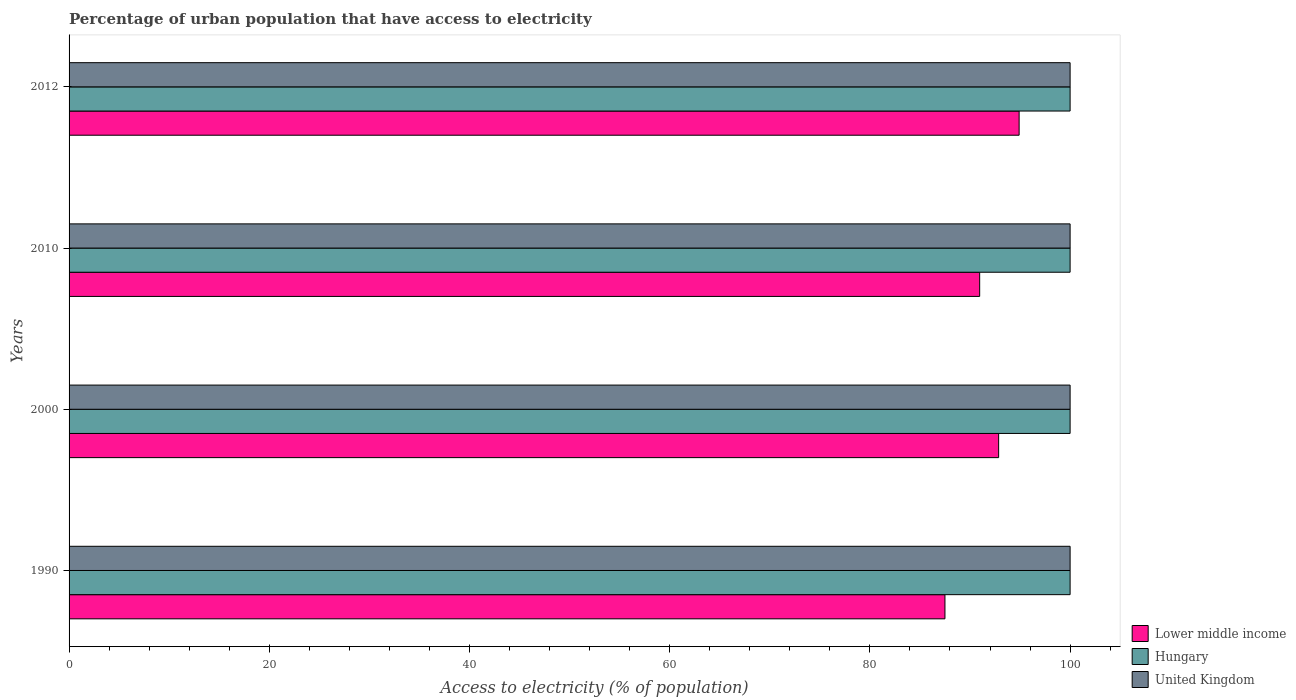How many different coloured bars are there?
Provide a succinct answer. 3. What is the label of the 3rd group of bars from the top?
Your answer should be compact. 2000. In how many cases, is the number of bars for a given year not equal to the number of legend labels?
Give a very brief answer. 0. What is the percentage of urban population that have access to electricity in Hungary in 1990?
Make the answer very short. 100. Across all years, what is the maximum percentage of urban population that have access to electricity in United Kingdom?
Ensure brevity in your answer.  100. Across all years, what is the minimum percentage of urban population that have access to electricity in United Kingdom?
Your answer should be very brief. 100. What is the total percentage of urban population that have access to electricity in United Kingdom in the graph?
Make the answer very short. 400. What is the difference between the percentage of urban population that have access to electricity in Hungary in 1990 and that in 2010?
Your answer should be very brief. 0. What is the difference between the percentage of urban population that have access to electricity in Hungary in 1990 and the percentage of urban population that have access to electricity in Lower middle income in 2000?
Your answer should be very brief. 7.14. In the year 2000, what is the difference between the percentage of urban population that have access to electricity in Lower middle income and percentage of urban population that have access to electricity in United Kingdom?
Keep it short and to the point. -7.14. What is the ratio of the percentage of urban population that have access to electricity in Lower middle income in 2010 to that in 2012?
Ensure brevity in your answer.  0.96. Is the difference between the percentage of urban population that have access to electricity in Lower middle income in 2000 and 2012 greater than the difference between the percentage of urban population that have access to electricity in United Kingdom in 2000 and 2012?
Provide a succinct answer. No. What does the 1st bar from the top in 2000 represents?
Offer a terse response. United Kingdom. What does the 1st bar from the bottom in 2000 represents?
Your answer should be very brief. Lower middle income. Is it the case that in every year, the sum of the percentage of urban population that have access to electricity in Hungary and percentage of urban population that have access to electricity in Lower middle income is greater than the percentage of urban population that have access to electricity in United Kingdom?
Your response must be concise. Yes. Are all the bars in the graph horizontal?
Your response must be concise. Yes. How many years are there in the graph?
Your answer should be very brief. 4. What is the difference between two consecutive major ticks on the X-axis?
Provide a succinct answer. 20. Are the values on the major ticks of X-axis written in scientific E-notation?
Keep it short and to the point. No. Where does the legend appear in the graph?
Offer a very short reply. Bottom right. How many legend labels are there?
Your answer should be very brief. 3. What is the title of the graph?
Offer a terse response. Percentage of urban population that have access to electricity. Does "Luxembourg" appear as one of the legend labels in the graph?
Offer a very short reply. No. What is the label or title of the X-axis?
Ensure brevity in your answer.  Access to electricity (% of population). What is the Access to electricity (% of population) in Lower middle income in 1990?
Make the answer very short. 87.5. What is the Access to electricity (% of population) of United Kingdom in 1990?
Your response must be concise. 100. What is the Access to electricity (% of population) of Lower middle income in 2000?
Offer a terse response. 92.86. What is the Access to electricity (% of population) of Lower middle income in 2010?
Your answer should be very brief. 90.97. What is the Access to electricity (% of population) in Lower middle income in 2012?
Provide a short and direct response. 94.91. What is the Access to electricity (% of population) in Hungary in 2012?
Offer a terse response. 100. What is the Access to electricity (% of population) in United Kingdom in 2012?
Your response must be concise. 100. Across all years, what is the maximum Access to electricity (% of population) in Lower middle income?
Make the answer very short. 94.91. Across all years, what is the maximum Access to electricity (% of population) in United Kingdom?
Keep it short and to the point. 100. Across all years, what is the minimum Access to electricity (% of population) of Lower middle income?
Offer a very short reply. 87.5. What is the total Access to electricity (% of population) in Lower middle income in the graph?
Your answer should be compact. 366.23. What is the total Access to electricity (% of population) of Hungary in the graph?
Keep it short and to the point. 400. What is the difference between the Access to electricity (% of population) in Lower middle income in 1990 and that in 2000?
Give a very brief answer. -5.36. What is the difference between the Access to electricity (% of population) of Hungary in 1990 and that in 2000?
Offer a terse response. 0. What is the difference between the Access to electricity (% of population) in Lower middle income in 1990 and that in 2010?
Your response must be concise. -3.47. What is the difference between the Access to electricity (% of population) in Hungary in 1990 and that in 2010?
Offer a very short reply. 0. What is the difference between the Access to electricity (% of population) of United Kingdom in 1990 and that in 2010?
Offer a very short reply. 0. What is the difference between the Access to electricity (% of population) of Lower middle income in 1990 and that in 2012?
Your answer should be compact. -7.41. What is the difference between the Access to electricity (% of population) in Hungary in 1990 and that in 2012?
Your answer should be very brief. 0. What is the difference between the Access to electricity (% of population) in Lower middle income in 2000 and that in 2010?
Make the answer very short. 1.9. What is the difference between the Access to electricity (% of population) in United Kingdom in 2000 and that in 2010?
Provide a succinct answer. 0. What is the difference between the Access to electricity (% of population) of Lower middle income in 2000 and that in 2012?
Keep it short and to the point. -2.05. What is the difference between the Access to electricity (% of population) of Hungary in 2000 and that in 2012?
Make the answer very short. 0. What is the difference between the Access to electricity (% of population) in United Kingdom in 2000 and that in 2012?
Keep it short and to the point. 0. What is the difference between the Access to electricity (% of population) of Lower middle income in 2010 and that in 2012?
Your answer should be very brief. -3.94. What is the difference between the Access to electricity (% of population) in Hungary in 2010 and that in 2012?
Give a very brief answer. 0. What is the difference between the Access to electricity (% of population) in United Kingdom in 2010 and that in 2012?
Ensure brevity in your answer.  0. What is the difference between the Access to electricity (% of population) of Lower middle income in 1990 and the Access to electricity (% of population) of Hungary in 2000?
Ensure brevity in your answer.  -12.5. What is the difference between the Access to electricity (% of population) in Lower middle income in 1990 and the Access to electricity (% of population) in United Kingdom in 2000?
Offer a terse response. -12.5. What is the difference between the Access to electricity (% of population) of Lower middle income in 1990 and the Access to electricity (% of population) of Hungary in 2010?
Keep it short and to the point. -12.5. What is the difference between the Access to electricity (% of population) of Lower middle income in 1990 and the Access to electricity (% of population) of United Kingdom in 2010?
Your answer should be compact. -12.5. What is the difference between the Access to electricity (% of population) in Lower middle income in 1990 and the Access to electricity (% of population) in Hungary in 2012?
Keep it short and to the point. -12.5. What is the difference between the Access to electricity (% of population) of Lower middle income in 1990 and the Access to electricity (% of population) of United Kingdom in 2012?
Provide a short and direct response. -12.5. What is the difference between the Access to electricity (% of population) in Lower middle income in 2000 and the Access to electricity (% of population) in Hungary in 2010?
Provide a short and direct response. -7.14. What is the difference between the Access to electricity (% of population) in Lower middle income in 2000 and the Access to electricity (% of population) in United Kingdom in 2010?
Your answer should be very brief. -7.14. What is the difference between the Access to electricity (% of population) in Lower middle income in 2000 and the Access to electricity (% of population) in Hungary in 2012?
Ensure brevity in your answer.  -7.14. What is the difference between the Access to electricity (% of population) of Lower middle income in 2000 and the Access to electricity (% of population) of United Kingdom in 2012?
Keep it short and to the point. -7.14. What is the difference between the Access to electricity (% of population) of Lower middle income in 2010 and the Access to electricity (% of population) of Hungary in 2012?
Provide a short and direct response. -9.03. What is the difference between the Access to electricity (% of population) of Lower middle income in 2010 and the Access to electricity (% of population) of United Kingdom in 2012?
Keep it short and to the point. -9.03. What is the average Access to electricity (% of population) of Lower middle income per year?
Ensure brevity in your answer.  91.56. In the year 1990, what is the difference between the Access to electricity (% of population) of Lower middle income and Access to electricity (% of population) of Hungary?
Ensure brevity in your answer.  -12.5. In the year 1990, what is the difference between the Access to electricity (% of population) in Lower middle income and Access to electricity (% of population) in United Kingdom?
Give a very brief answer. -12.5. In the year 1990, what is the difference between the Access to electricity (% of population) of Hungary and Access to electricity (% of population) of United Kingdom?
Your response must be concise. 0. In the year 2000, what is the difference between the Access to electricity (% of population) in Lower middle income and Access to electricity (% of population) in Hungary?
Provide a short and direct response. -7.14. In the year 2000, what is the difference between the Access to electricity (% of population) in Lower middle income and Access to electricity (% of population) in United Kingdom?
Offer a terse response. -7.14. In the year 2000, what is the difference between the Access to electricity (% of population) in Hungary and Access to electricity (% of population) in United Kingdom?
Offer a terse response. 0. In the year 2010, what is the difference between the Access to electricity (% of population) in Lower middle income and Access to electricity (% of population) in Hungary?
Your response must be concise. -9.03. In the year 2010, what is the difference between the Access to electricity (% of population) in Lower middle income and Access to electricity (% of population) in United Kingdom?
Make the answer very short. -9.03. In the year 2010, what is the difference between the Access to electricity (% of population) of Hungary and Access to electricity (% of population) of United Kingdom?
Provide a short and direct response. 0. In the year 2012, what is the difference between the Access to electricity (% of population) in Lower middle income and Access to electricity (% of population) in Hungary?
Your answer should be very brief. -5.09. In the year 2012, what is the difference between the Access to electricity (% of population) in Lower middle income and Access to electricity (% of population) in United Kingdom?
Provide a succinct answer. -5.09. What is the ratio of the Access to electricity (% of population) of Lower middle income in 1990 to that in 2000?
Give a very brief answer. 0.94. What is the ratio of the Access to electricity (% of population) in Lower middle income in 1990 to that in 2010?
Your answer should be compact. 0.96. What is the ratio of the Access to electricity (% of population) in Hungary in 1990 to that in 2010?
Provide a succinct answer. 1. What is the ratio of the Access to electricity (% of population) in United Kingdom in 1990 to that in 2010?
Your answer should be compact. 1. What is the ratio of the Access to electricity (% of population) in Lower middle income in 1990 to that in 2012?
Offer a very short reply. 0.92. What is the ratio of the Access to electricity (% of population) of Hungary in 1990 to that in 2012?
Provide a short and direct response. 1. What is the ratio of the Access to electricity (% of population) of United Kingdom in 1990 to that in 2012?
Your answer should be very brief. 1. What is the ratio of the Access to electricity (% of population) in Lower middle income in 2000 to that in 2010?
Provide a short and direct response. 1.02. What is the ratio of the Access to electricity (% of population) in Hungary in 2000 to that in 2010?
Provide a succinct answer. 1. What is the ratio of the Access to electricity (% of population) in Lower middle income in 2000 to that in 2012?
Your answer should be very brief. 0.98. What is the ratio of the Access to electricity (% of population) of Hungary in 2000 to that in 2012?
Your response must be concise. 1. What is the ratio of the Access to electricity (% of population) in Lower middle income in 2010 to that in 2012?
Offer a very short reply. 0.96. What is the difference between the highest and the second highest Access to electricity (% of population) of Lower middle income?
Your answer should be compact. 2.05. What is the difference between the highest and the lowest Access to electricity (% of population) in Lower middle income?
Make the answer very short. 7.41. What is the difference between the highest and the lowest Access to electricity (% of population) in United Kingdom?
Provide a succinct answer. 0. 